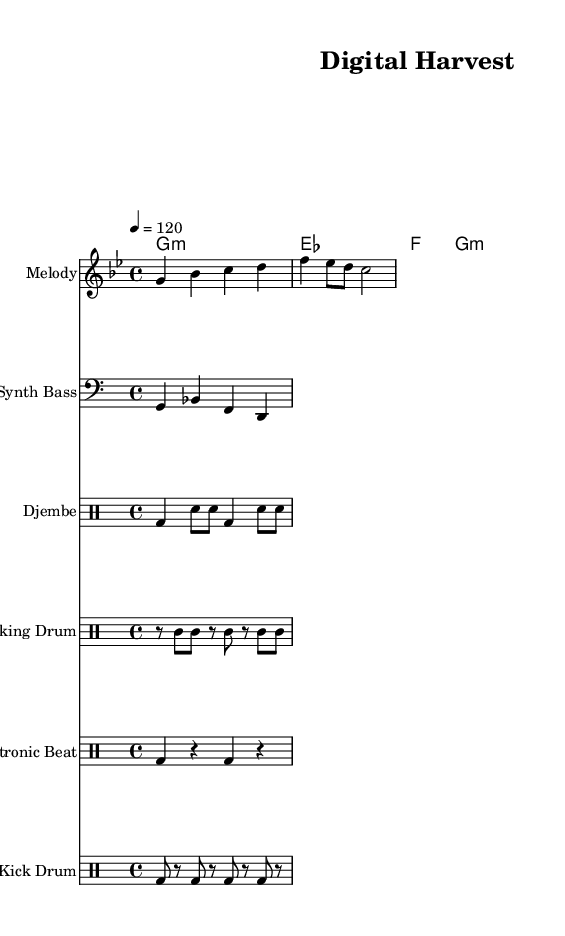What is the key signature of this music? The key signature is indicated by the flats present. In this case, there are two flats (B flat and E flat) on the staff, which identify the key as G minor.
Answer: G minor What is the time signature of this music? The time signature is shown at the beginning of the score as "4/4", indicating four beats per measure and that each beat is a quarter note.
Answer: 4/4 What is the tempo marking for this piece? The tempo marking, indicated above the staff with "4 = 120", specifies that there are 120 beats per minute, meaning the quarter note is counted as 120 beats in one minute.
Answer: 120 How many distinct percussion elements are present in this music? The score contains four distinct percussion parts: Djembe, Talking Drum, Electronic Beat, and Kick Drum. This is counted by looking at the separate drum staff sections.
Answer: Four What is the first note of the melody? The melody starts on the note G, as indicated in the first measure of the score. This is found by looking at the notes written in the melody staff.
Answer: G Which two instruments play the same rhythm pattern in the percussion section? The Djembe and Talking Drum share rhythmic elements, as they both feature rhythmic patterns that emphasize varying notes, providing a cross-sectional view of how traditional rhythms combine in the score.
Answer: Djembe and Talking Drum 